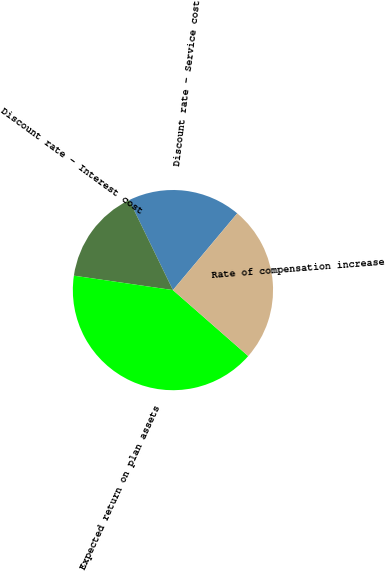Convert chart to OTSL. <chart><loc_0><loc_0><loc_500><loc_500><pie_chart><fcel>Discount rate - Service cost<fcel>Discount rate - Interest cost<fcel>Expected return on plan assets<fcel>Rate of compensation increase<nl><fcel>18.31%<fcel>15.49%<fcel>40.85%<fcel>25.35%<nl></chart> 